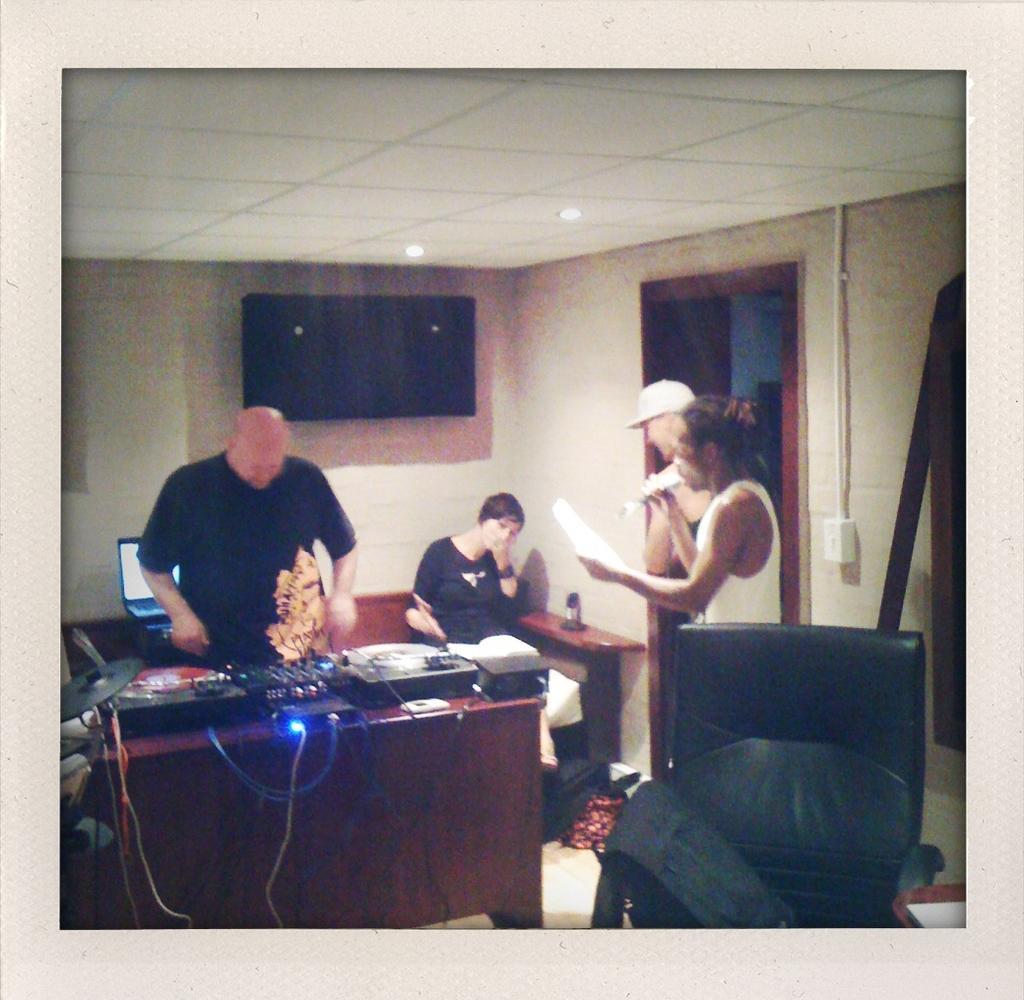Can you describe this image briefly? In this picture we can see a a person is standing, and in front here is the table and some objects on it, and here a person is sitting, and at back here is the wall, and here a person is standing and holding something in the hand. 